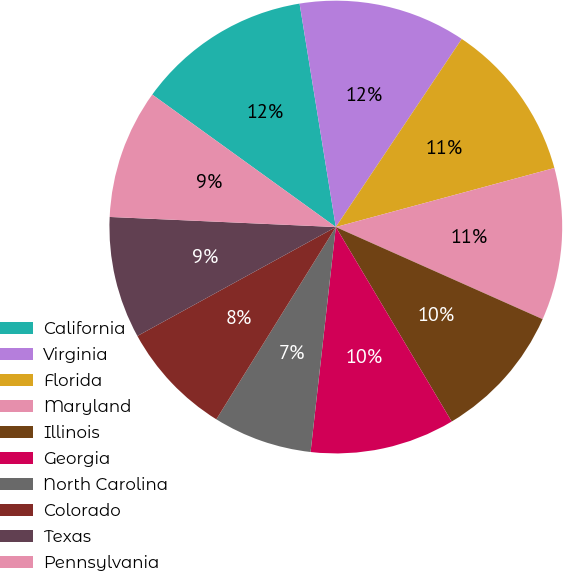<chart> <loc_0><loc_0><loc_500><loc_500><pie_chart><fcel>California<fcel>Virginia<fcel>Florida<fcel>Maryland<fcel>Illinois<fcel>Georgia<fcel>North Carolina<fcel>Colorado<fcel>Texas<fcel>Pennsylvania<nl><fcel>12.49%<fcel>11.95%<fcel>11.41%<fcel>10.87%<fcel>9.78%<fcel>10.33%<fcel>7.07%<fcel>8.16%<fcel>8.7%<fcel>9.24%<nl></chart> 